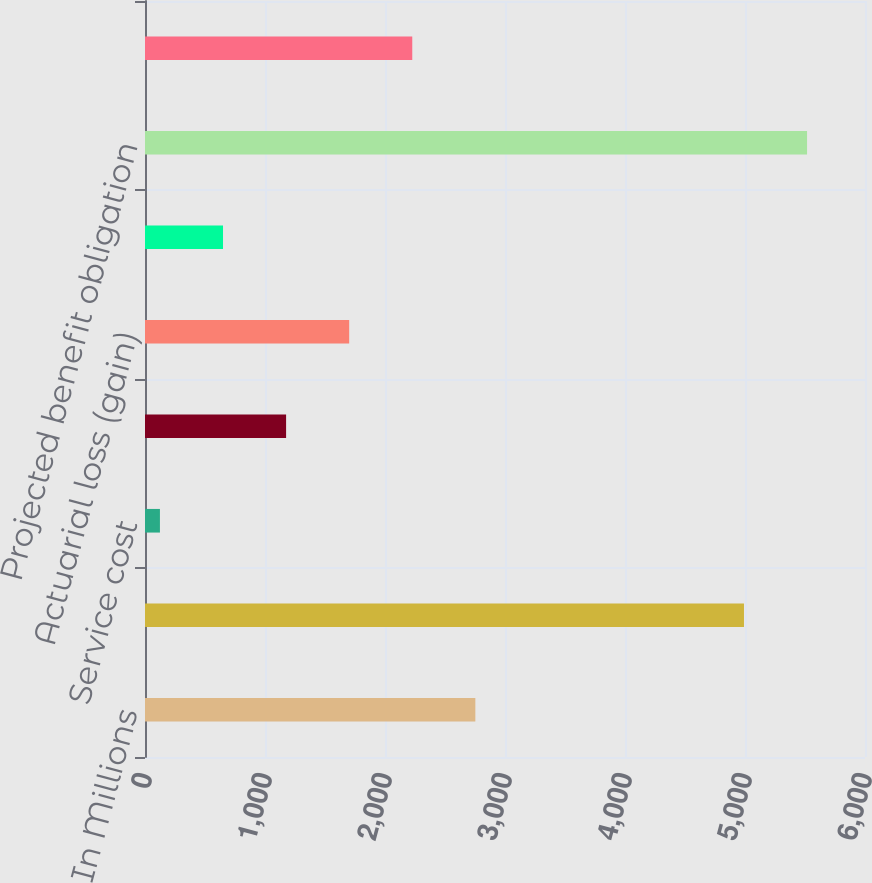Convert chart. <chart><loc_0><loc_0><loc_500><loc_500><bar_chart><fcel>In Millions<fcel>Benefit obligation at<fcel>Service cost<fcel>Interest cost<fcel>Actuarial loss (gain)<fcel>Benefits payments<fcel>Projected benefit obligation<fcel>obligation as of fiscal year<nl><fcel>2752.9<fcel>4991.5<fcel>124.4<fcel>1175.8<fcel>1701.5<fcel>650.1<fcel>5517.2<fcel>2227.2<nl></chart> 